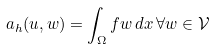Convert formula to latex. <formula><loc_0><loc_0><loc_500><loc_500>a _ { h } ( u , w ) = \int _ { \Omega } f w \, d x \, \forall w \in \mathcal { V }</formula> 